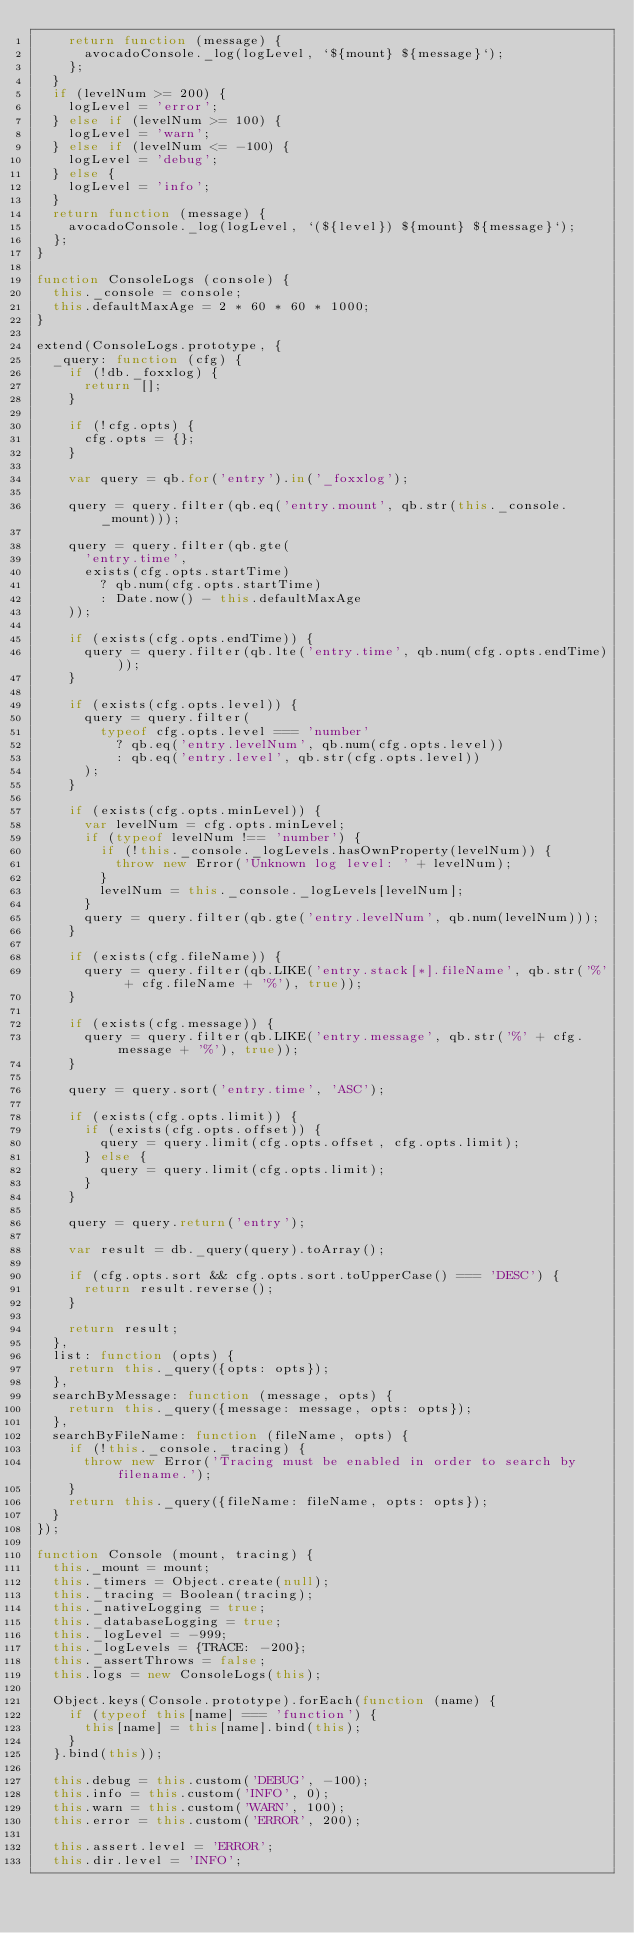<code> <loc_0><loc_0><loc_500><loc_500><_JavaScript_>    return function (message) {
      avocadoConsole._log(logLevel, `${mount} ${message}`);
    };
  }
  if (levelNum >= 200) {
    logLevel = 'error';
  } else if (levelNum >= 100) {
    logLevel = 'warn';
  } else if (levelNum <= -100) {
    logLevel = 'debug';
  } else {
    logLevel = 'info';
  }
  return function (message) {
    avocadoConsole._log(logLevel, `(${level}) ${mount} ${message}`);
  };
}

function ConsoleLogs (console) {
  this._console = console;
  this.defaultMaxAge = 2 * 60 * 60 * 1000;
}

extend(ConsoleLogs.prototype, {
  _query: function (cfg) {
    if (!db._foxxlog) {
      return [];
    }

    if (!cfg.opts) {
      cfg.opts = {};
    }

    var query = qb.for('entry').in('_foxxlog');

    query = query.filter(qb.eq('entry.mount', qb.str(this._console._mount)));

    query = query.filter(qb.gte(
      'entry.time',
      exists(cfg.opts.startTime)
        ? qb.num(cfg.opts.startTime)
        : Date.now() - this.defaultMaxAge
    ));

    if (exists(cfg.opts.endTime)) {
      query = query.filter(qb.lte('entry.time', qb.num(cfg.opts.endTime)));
    }

    if (exists(cfg.opts.level)) {
      query = query.filter(
        typeof cfg.opts.level === 'number'
          ? qb.eq('entry.levelNum', qb.num(cfg.opts.level))
          : qb.eq('entry.level', qb.str(cfg.opts.level))
      );
    }

    if (exists(cfg.opts.minLevel)) {
      var levelNum = cfg.opts.minLevel;
      if (typeof levelNum !== 'number') {
        if (!this._console._logLevels.hasOwnProperty(levelNum)) {
          throw new Error('Unknown log level: ' + levelNum);
        }
        levelNum = this._console._logLevels[levelNum];
      }
      query = query.filter(qb.gte('entry.levelNum', qb.num(levelNum)));
    }

    if (exists(cfg.fileName)) {
      query = query.filter(qb.LIKE('entry.stack[*].fileName', qb.str('%' + cfg.fileName + '%'), true));
    }

    if (exists(cfg.message)) {
      query = query.filter(qb.LIKE('entry.message', qb.str('%' + cfg.message + '%'), true));
    }

    query = query.sort('entry.time', 'ASC');

    if (exists(cfg.opts.limit)) {
      if (exists(cfg.opts.offset)) {
        query = query.limit(cfg.opts.offset, cfg.opts.limit);
      } else {
        query = query.limit(cfg.opts.limit);
      }
    }

    query = query.return('entry');

    var result = db._query(query).toArray();

    if (cfg.opts.sort && cfg.opts.sort.toUpperCase() === 'DESC') {
      return result.reverse();
    }

    return result;
  },
  list: function (opts) {
    return this._query({opts: opts});
  },
  searchByMessage: function (message, opts) {
    return this._query({message: message, opts: opts});
  },
  searchByFileName: function (fileName, opts) {
    if (!this._console._tracing) {
      throw new Error('Tracing must be enabled in order to search by filename.');
    }
    return this._query({fileName: fileName, opts: opts});
  }
});

function Console (mount, tracing) {
  this._mount = mount;
  this._timers = Object.create(null);
  this._tracing = Boolean(tracing);
  this._nativeLogging = true;
  this._databaseLogging = true;
  this._logLevel = -999;
  this._logLevels = {TRACE: -200};
  this._assertThrows = false;
  this.logs = new ConsoleLogs(this);

  Object.keys(Console.prototype).forEach(function (name) {
    if (typeof this[name] === 'function') {
      this[name] = this[name].bind(this);
    }
  }.bind(this));

  this.debug = this.custom('DEBUG', -100);
  this.info = this.custom('INFO', 0);
  this.warn = this.custom('WARN', 100);
  this.error = this.custom('ERROR', 200);

  this.assert.level = 'ERROR';
  this.dir.level = 'INFO';</code> 